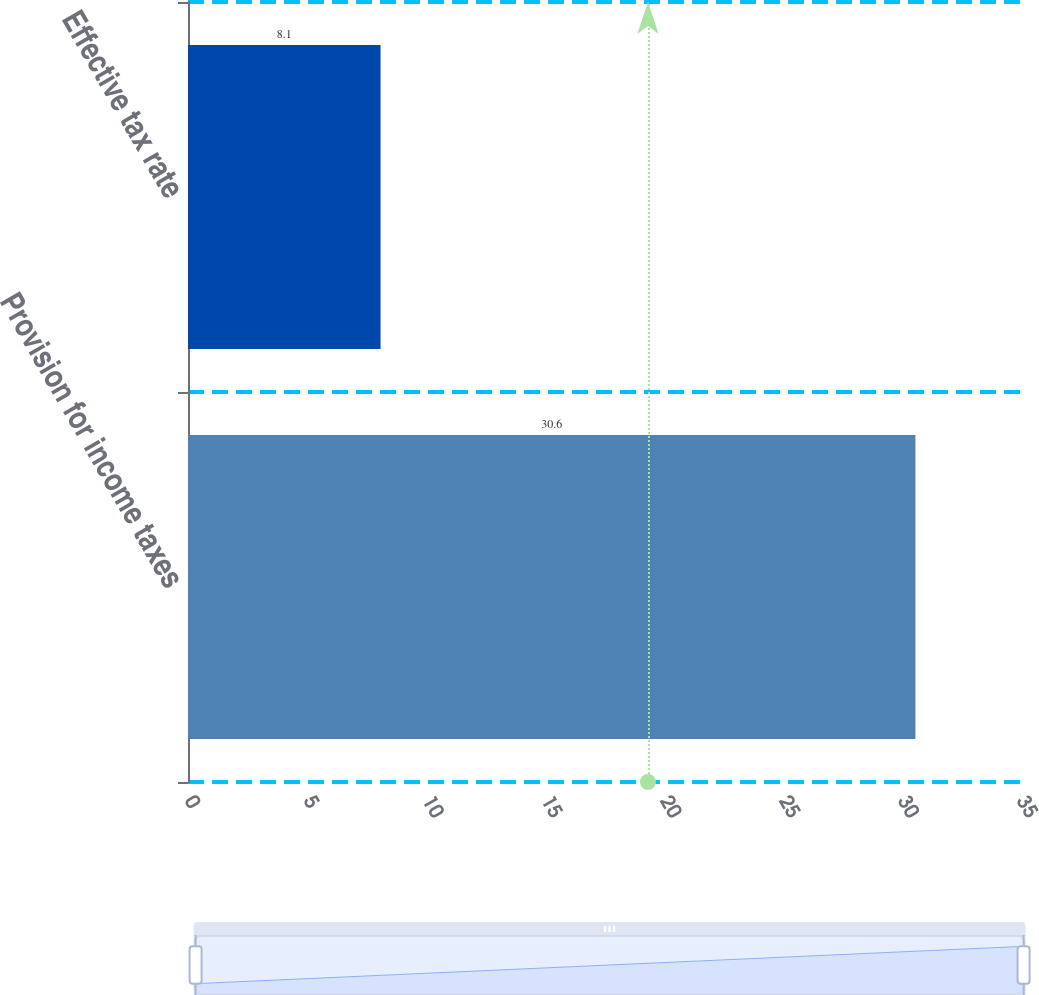Convert chart. <chart><loc_0><loc_0><loc_500><loc_500><bar_chart><fcel>Provision for income taxes<fcel>Effective tax rate<nl><fcel>30.6<fcel>8.1<nl></chart> 